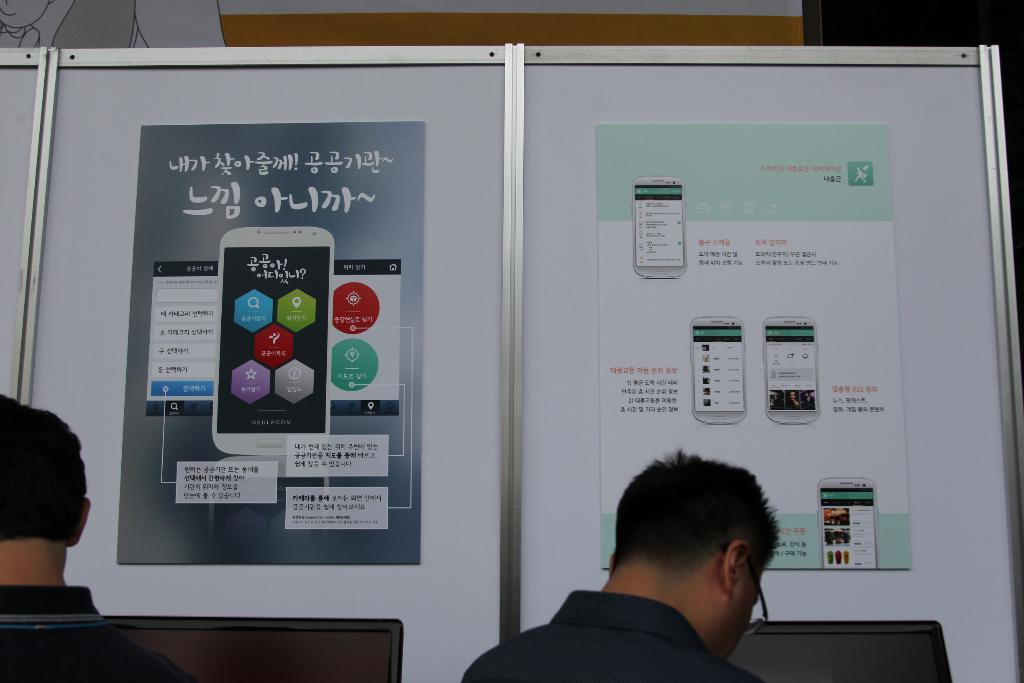Please provide a concise description of this image. In this image we can see two persons standing in front of board on which we can see two posters. One person is wearing spectacles. 